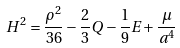Convert formula to latex. <formula><loc_0><loc_0><loc_500><loc_500>H ^ { 2 } = \frac { \rho ^ { 2 } } { 3 6 } - \frac { 2 } { 3 } Q - \frac { 1 } { 9 } E + \frac { \mu } { a ^ { 4 } }</formula> 